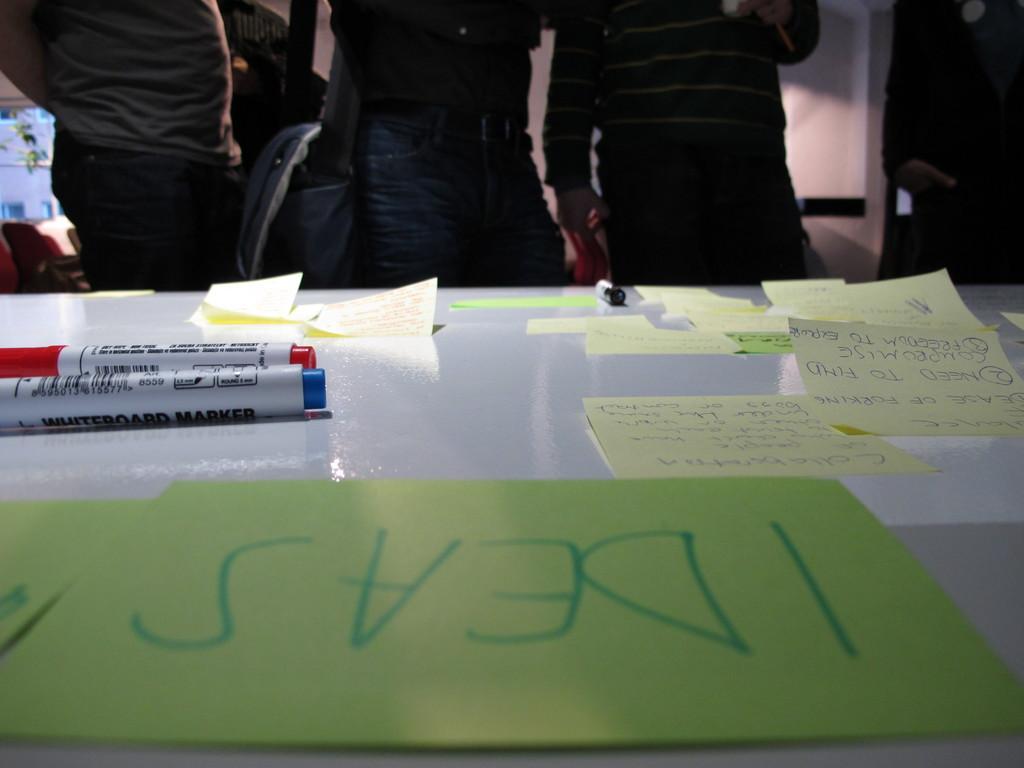In one or two sentences, can you explain what this image depicts? In this picture we can see a white table on which there are markers and sticky notes with some text written on them. In the background, we can see people standing near the chairs. 